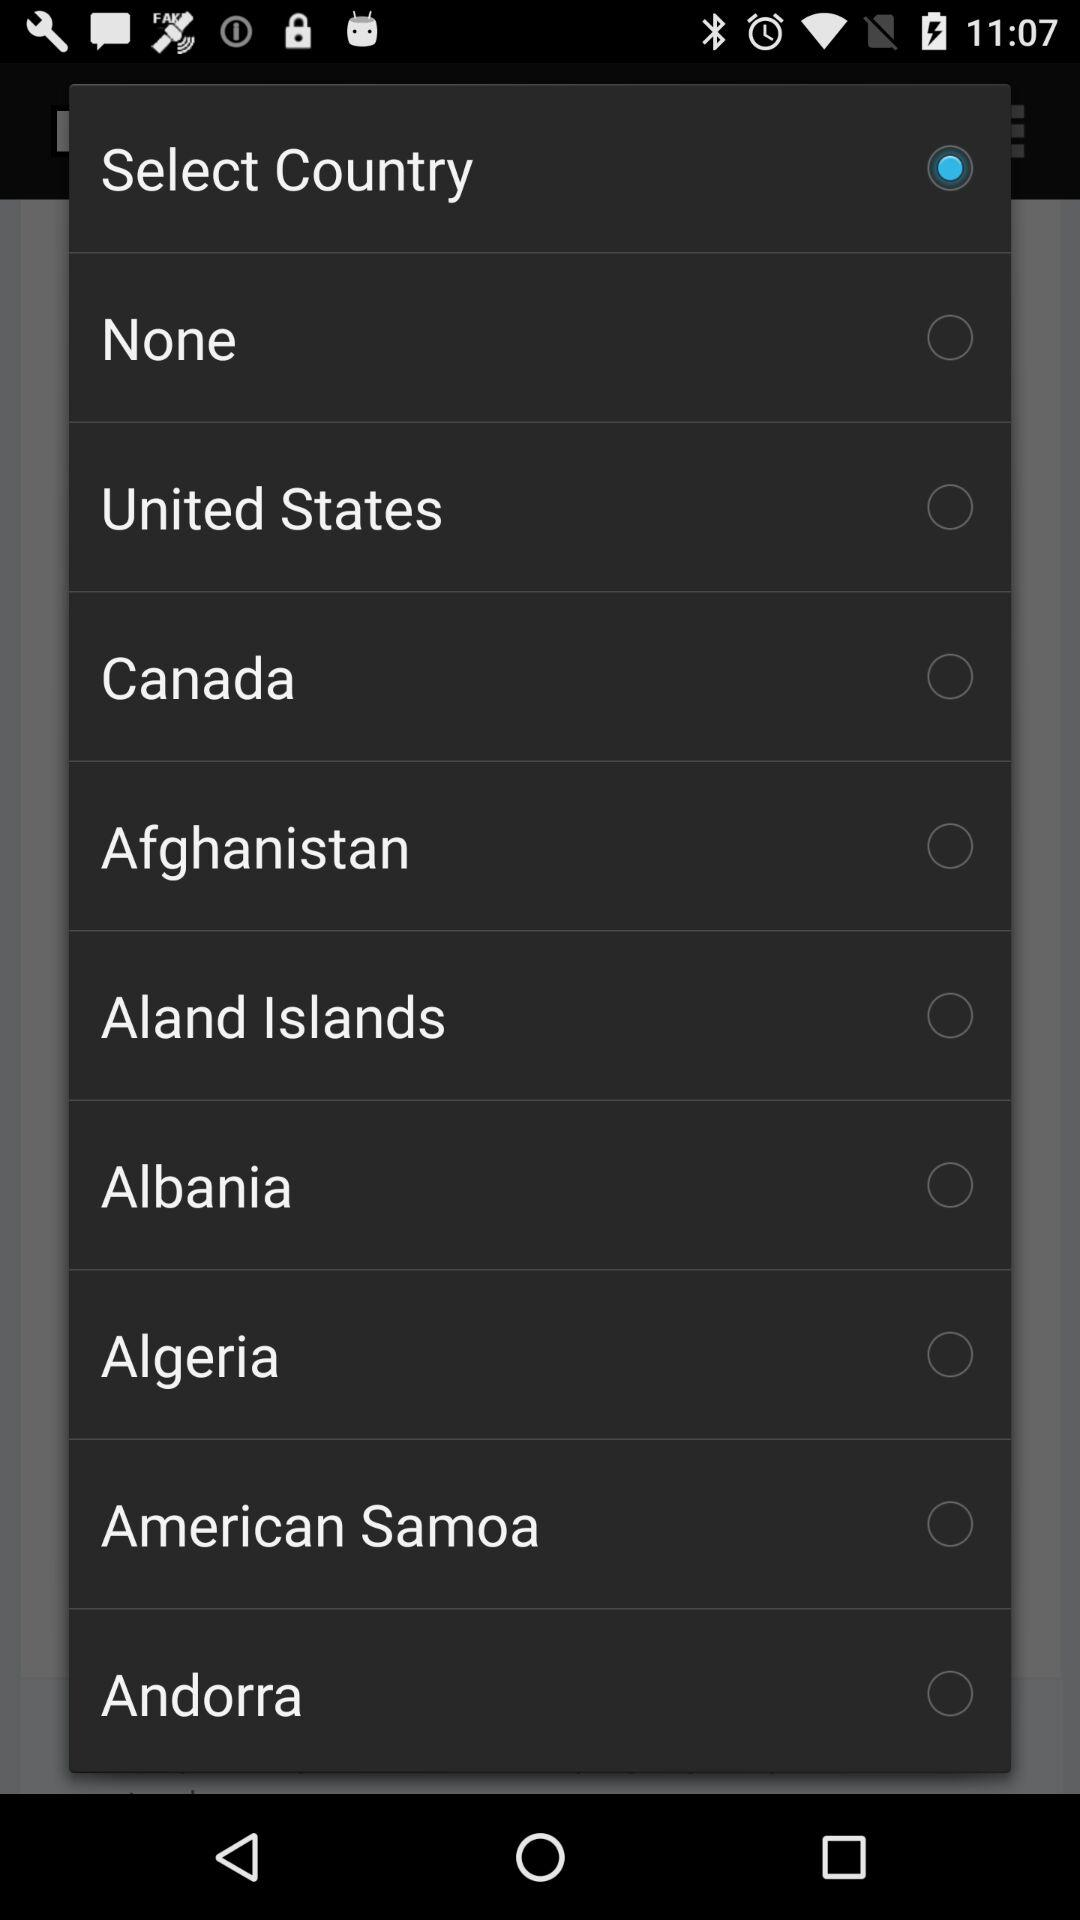Is "Algeria" selected or not? "Algeria" is not selected. 